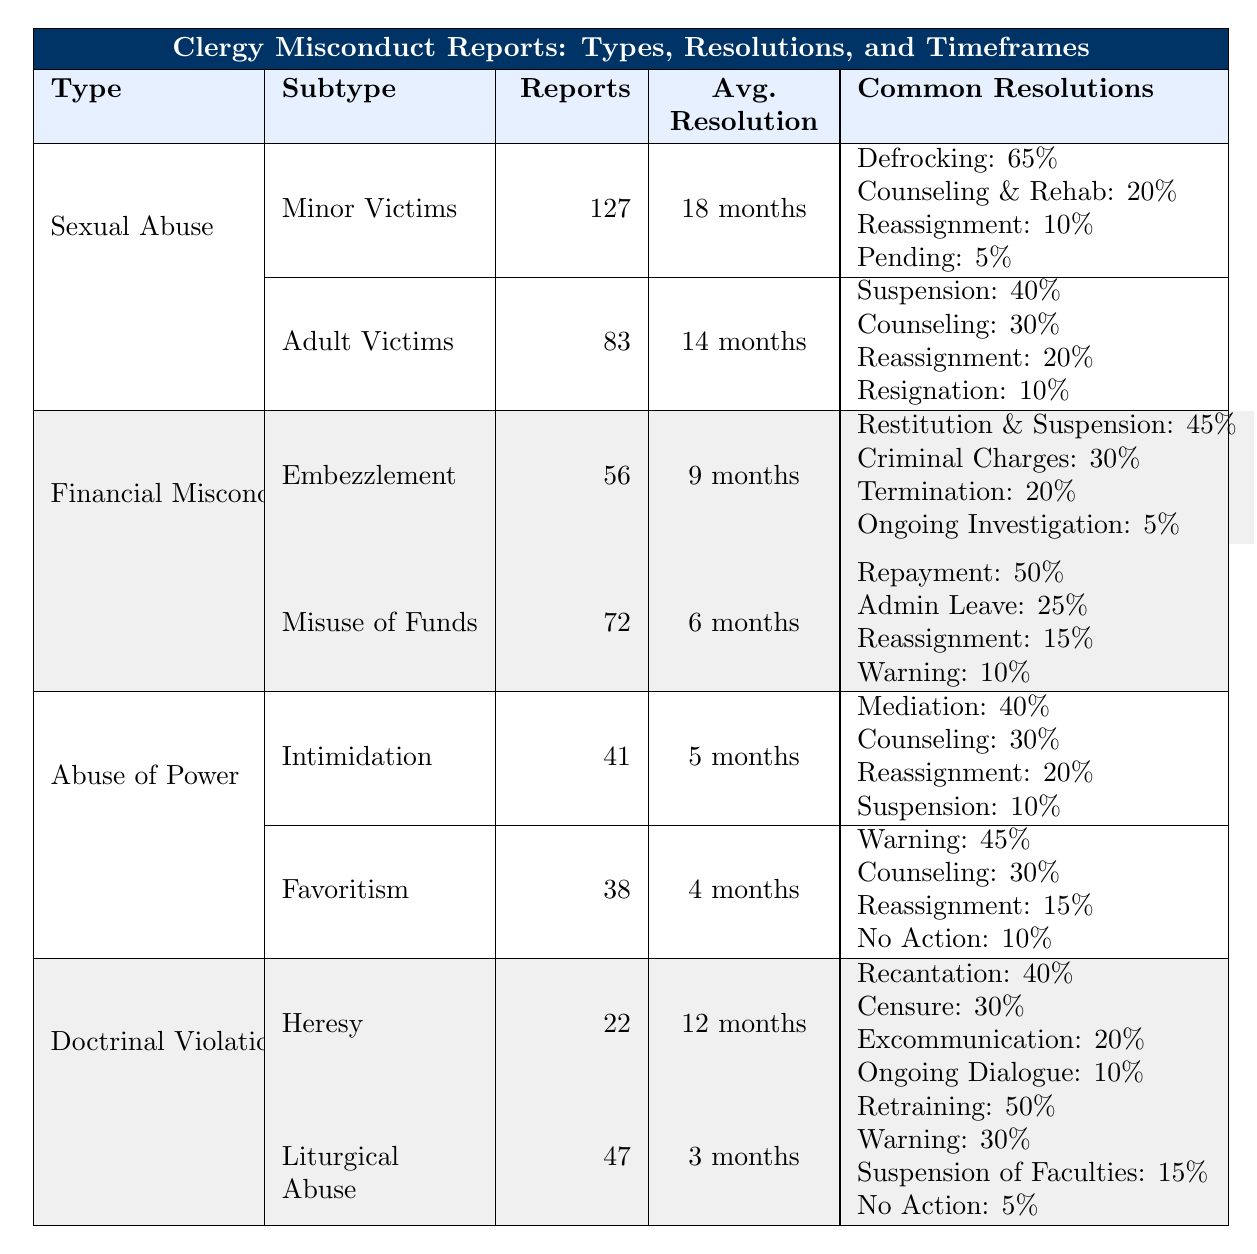What type of misconduct has the highest number of reports? The table shows the total number of reports for each type of misconduct. Sexual Abuse has 210 reports (127 for Minor Victims and 83 for Adult Victims), which is the highest.
Answer: Sexual Abuse What is the average resolution time for Financial Misconduct? For Financial Misconduct, there are two subtypes with average resolution times of 9 months for Embezzlement and 6 months for Misuse of Church Funds. The average is (9 + 6) / 2 = 7.5 months.
Answer: 7.5 months Which resolution is most common for Litergical Abuse? The common resolutions for Liturgical Abuse are listed, with Retraining at 50%, Warning at 30%, Suspension of Faculties at 15%, and No Action at 5%. Retraining is the most common.
Answer: Retraining Is the average resolution time for Abuse of Power less than 6 months? The average resolution time for Intimidation is 5 months, and for Favoritism, it is 4 months. Both are less than 6 months.
Answer: Yes What percentage of reports for Sexual Abuse involved Minor Victims? Minor Victims have 127 reports while Adult Victims have 83 reports. The total is 210. The percentage for Minor Victims is (127 / 210) * 100 = 60.95%, which rounds to 61%.
Answer: 61% Which type of misconduct has the lowest resolution time and what is it? The lowest average resolution time is for Favoritism at 4 months.
Answer: Favoritism, 4 months Are more reports filed for Financial Misconduct or Abuse of Power? Financial Misconduct has a total of 128 reports (56 for Embezzlement and 72 for Misuse of Funds) while Abuse of Power has 79 reports (41 for Intimidation and 38 for Favoritism). Thus, more reports are filed for Financial Misconduct.
Answer: Financial Misconduct What are the common resolutions for Sexual Abuse involving Minor Victims? The table lists the common resolutions for Minor Victims under Sexual Abuse: Defrocking (65%), Counseling and Rehabilitation (20%), Reassignment (10%), and Pending (5%).
Answer: Defrocking, Counseling and Rehabilitation, Reassignment, Pending What is the difference in average resolution time between Liturgical Abuse and Sexual Abuse involving Adult Victims? Liturgical Abuse has an average resolution time of 3 months, while Sexual Abuse involving Adult Victims has an average of 14 months. The difference is 14 - 3 = 11 months.
Answer: 11 months Are more than 40% of the resolutions for Financial Misconduct related to Restitution and Suspension? The common resolutions for Financial Misconduct show that Restitution and Suspension comprise 45%, which is more than 40%.
Answer: Yes 